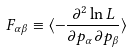<formula> <loc_0><loc_0><loc_500><loc_500>F _ { \alpha \beta } \equiv \langle - \frac { \partial ^ { 2 } \ln L } { \partial p _ { \alpha } \partial p _ { \beta } } \rangle</formula> 